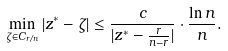Convert formula to latex. <formula><loc_0><loc_0><loc_500><loc_500>\min _ { \zeta \in C _ { r / n } } | z ^ { * } - \zeta | \leq \frac { c } { | z ^ { * } - \frac { r } { n - r } | } \cdot \frac { \ln n } { n } .</formula> 